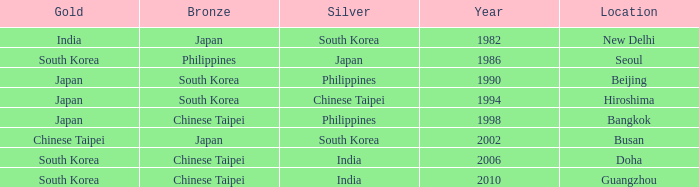Which Location has a Silver of japan? Seoul. 